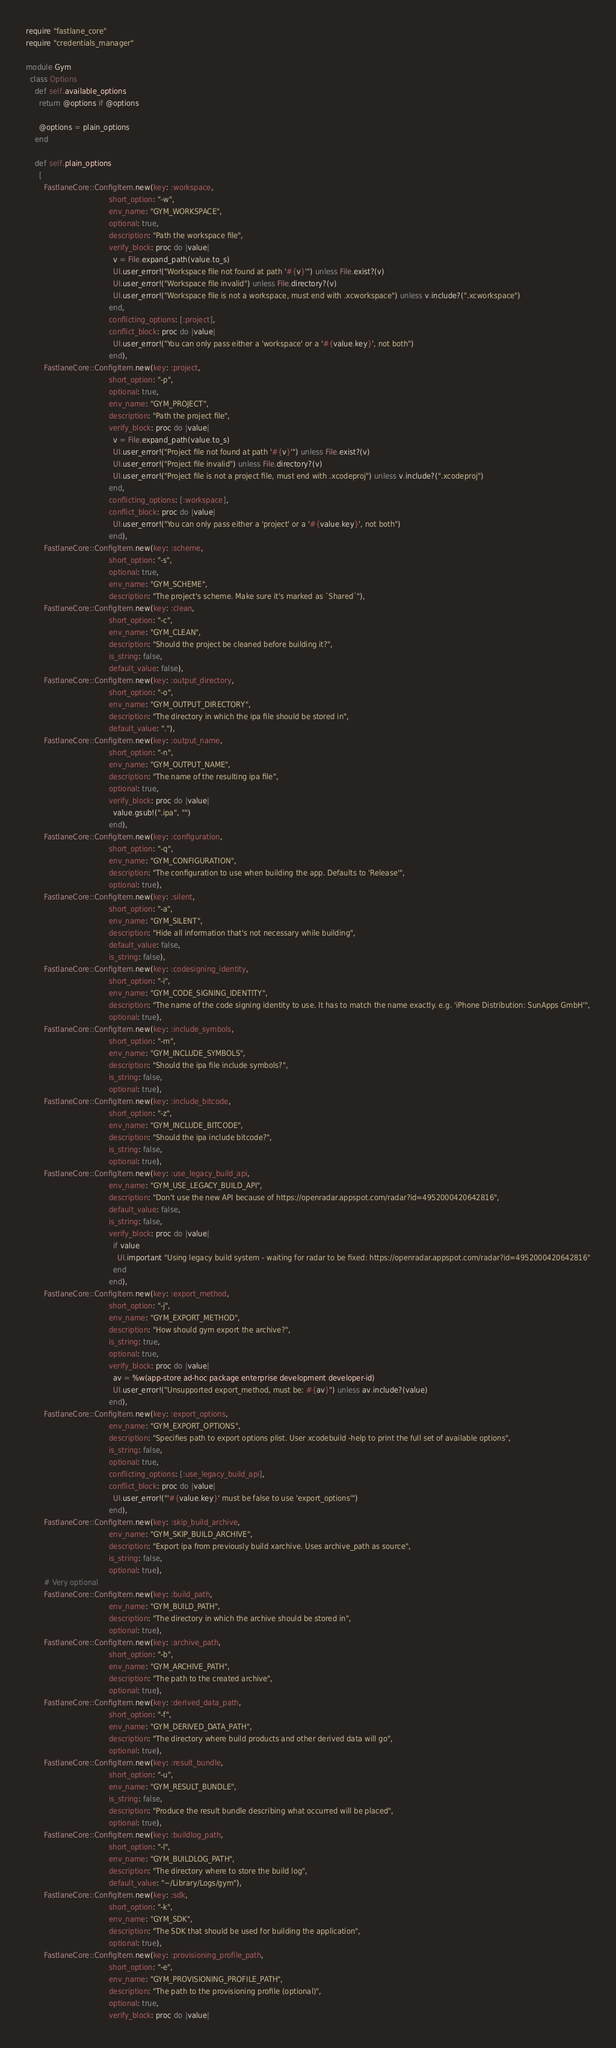Convert code to text. <code><loc_0><loc_0><loc_500><loc_500><_Ruby_>require "fastlane_core"
require "credentials_manager"

module Gym
  class Options
    def self.available_options
      return @options if @options

      @options = plain_options
    end

    def self.plain_options
      [
        FastlaneCore::ConfigItem.new(key: :workspace,
                                     short_option: "-w",
                                     env_name: "GYM_WORKSPACE",
                                     optional: true,
                                     description: "Path the workspace file",
                                     verify_block: proc do |value|
                                       v = File.expand_path(value.to_s)
                                       UI.user_error!("Workspace file not found at path '#{v}'") unless File.exist?(v)
                                       UI.user_error!("Workspace file invalid") unless File.directory?(v)
                                       UI.user_error!("Workspace file is not a workspace, must end with .xcworkspace") unless v.include?(".xcworkspace")
                                     end,
                                     conflicting_options: [:project],
                                     conflict_block: proc do |value|
                                       UI.user_error!("You can only pass either a 'workspace' or a '#{value.key}', not both")
                                     end),
        FastlaneCore::ConfigItem.new(key: :project,
                                     short_option: "-p",
                                     optional: true,
                                     env_name: "GYM_PROJECT",
                                     description: "Path the project file",
                                     verify_block: proc do |value|
                                       v = File.expand_path(value.to_s)
                                       UI.user_error!("Project file not found at path '#{v}'") unless File.exist?(v)
                                       UI.user_error!("Project file invalid") unless File.directory?(v)
                                       UI.user_error!("Project file is not a project file, must end with .xcodeproj") unless v.include?(".xcodeproj")
                                     end,
                                     conflicting_options: [:workspace],
                                     conflict_block: proc do |value|
                                       UI.user_error!("You can only pass either a 'project' or a '#{value.key}', not both")
                                     end),
        FastlaneCore::ConfigItem.new(key: :scheme,
                                     short_option: "-s",
                                     optional: true,
                                     env_name: "GYM_SCHEME",
                                     description: "The project's scheme. Make sure it's marked as `Shared`"),
        FastlaneCore::ConfigItem.new(key: :clean,
                                     short_option: "-c",
                                     env_name: "GYM_CLEAN",
                                     description: "Should the project be cleaned before building it?",
                                     is_string: false,
                                     default_value: false),
        FastlaneCore::ConfigItem.new(key: :output_directory,
                                     short_option: "-o",
                                     env_name: "GYM_OUTPUT_DIRECTORY",
                                     description: "The directory in which the ipa file should be stored in",
                                     default_value: "."),
        FastlaneCore::ConfigItem.new(key: :output_name,
                                     short_option: "-n",
                                     env_name: "GYM_OUTPUT_NAME",
                                     description: "The name of the resulting ipa file",
                                     optional: true,
                                     verify_block: proc do |value|
                                       value.gsub!(".ipa", "")
                                     end),
        FastlaneCore::ConfigItem.new(key: :configuration,
                                     short_option: "-q",
                                     env_name: "GYM_CONFIGURATION",
                                     description: "The configuration to use when building the app. Defaults to 'Release'",
                                     optional: true),
        FastlaneCore::ConfigItem.new(key: :silent,
                                     short_option: "-a",
                                     env_name: "GYM_SILENT",
                                     description: "Hide all information that's not necessary while building",
                                     default_value: false,
                                     is_string: false),
        FastlaneCore::ConfigItem.new(key: :codesigning_identity,
                                     short_option: "-i",
                                     env_name: "GYM_CODE_SIGNING_IDENTITY",
                                     description: "The name of the code signing identity to use. It has to match the name exactly. e.g. 'iPhone Distribution: SunApps GmbH'",
                                     optional: true),
        FastlaneCore::ConfigItem.new(key: :include_symbols,
                                     short_option: "-m",
                                     env_name: "GYM_INCLUDE_SYMBOLS",
                                     description: "Should the ipa file include symbols?",
                                     is_string: false,
                                     optional: true),
        FastlaneCore::ConfigItem.new(key: :include_bitcode,
                                     short_option: "-z",
                                     env_name: "GYM_INCLUDE_BITCODE",
                                     description: "Should the ipa include bitcode?",
                                     is_string: false,
                                     optional: true),
        FastlaneCore::ConfigItem.new(key: :use_legacy_build_api,
                                     env_name: "GYM_USE_LEGACY_BUILD_API",
                                     description: "Don't use the new API because of https://openradar.appspot.com/radar?id=4952000420642816",
                                     default_value: false,
                                     is_string: false,
                                     verify_block: proc do |value|
                                       if value
                                         UI.important "Using legacy build system - waiting for radar to be fixed: https://openradar.appspot.com/radar?id=4952000420642816"
                                       end
                                     end),
        FastlaneCore::ConfigItem.new(key: :export_method,
                                     short_option: "-j",
                                     env_name: "GYM_EXPORT_METHOD",
                                     description: "How should gym export the archive?",
                                     is_string: true,
                                     optional: true,
                                     verify_block: proc do |value|
                                       av = %w(app-store ad-hoc package enterprise development developer-id)
                                       UI.user_error!("Unsupported export_method, must be: #{av}") unless av.include?(value)
                                     end),
        FastlaneCore::ConfigItem.new(key: :export_options,
                                     env_name: "GYM_EXPORT_OPTIONS",
                                     description: "Specifies path to export options plist. User xcodebuild -help to print the full set of available options",
                                     is_string: false,
                                     optional: true,
                                     conflicting_options: [:use_legacy_build_api],
                                     conflict_block: proc do |value|
                                       UI.user_error!("'#{value.key}' must be false to use 'export_options'")
                                     end),
        FastlaneCore::ConfigItem.new(key: :skip_build_archive,
                                     env_name: "GYM_SKIP_BUILD_ARCHIVE",
                                     description: "Export ipa from previously build xarchive. Uses archive_path as source",
                                     is_string: false,
                                     optional: true),
        # Very optional
        FastlaneCore::ConfigItem.new(key: :build_path,
                                     env_name: "GYM_BUILD_PATH",
                                     description: "The directory in which the archive should be stored in",
                                     optional: true),
        FastlaneCore::ConfigItem.new(key: :archive_path,
                                     short_option: "-b",
                                     env_name: "GYM_ARCHIVE_PATH",
                                     description: "The path to the created archive",
                                     optional: true),
        FastlaneCore::ConfigItem.new(key: :derived_data_path,
                                     short_option: "-f",
                                     env_name: "GYM_DERIVED_DATA_PATH",
                                     description: "The directory where build products and other derived data will go",
                                     optional: true),
        FastlaneCore::ConfigItem.new(key: :result_bundle,
                                     short_option: "-u",
                                     env_name: "GYM_RESULT_BUNDLE",
                                     is_string: false,
                                     description: "Produce the result bundle describing what occurred will be placed",
                                     optional: true),
        FastlaneCore::ConfigItem.new(key: :buildlog_path,
                                     short_option: "-l",
                                     env_name: "GYM_BUILDLOG_PATH",
                                     description: "The directory where to store the build log",
                                     default_value: "~/Library/Logs/gym"),
        FastlaneCore::ConfigItem.new(key: :sdk,
                                     short_option: "-k",
                                     env_name: "GYM_SDK",
                                     description: "The SDK that should be used for building the application",
                                     optional: true),
        FastlaneCore::ConfigItem.new(key: :provisioning_profile_path,
                                     short_option: "-e",
                                     env_name: "GYM_PROVISIONING_PROFILE_PATH",
                                     description: "The path to the provisioning profile (optional)",
                                     optional: true,
                                     verify_block: proc do |value|</code> 